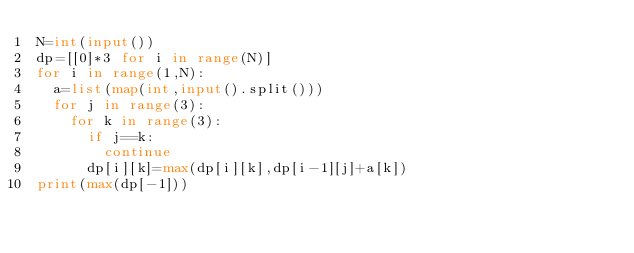<code> <loc_0><loc_0><loc_500><loc_500><_Python_>N=int(input())
dp=[[0]*3 for i in range(N)]
for i in range(1,N):
  a=list(map(int,input().split()))
  for j in range(3):
    for k in range(3):
      if j==k:
        continue
      dp[i][k]=max(dp[i][k],dp[i-1][j]+a[k])
print(max(dp[-1]))</code> 